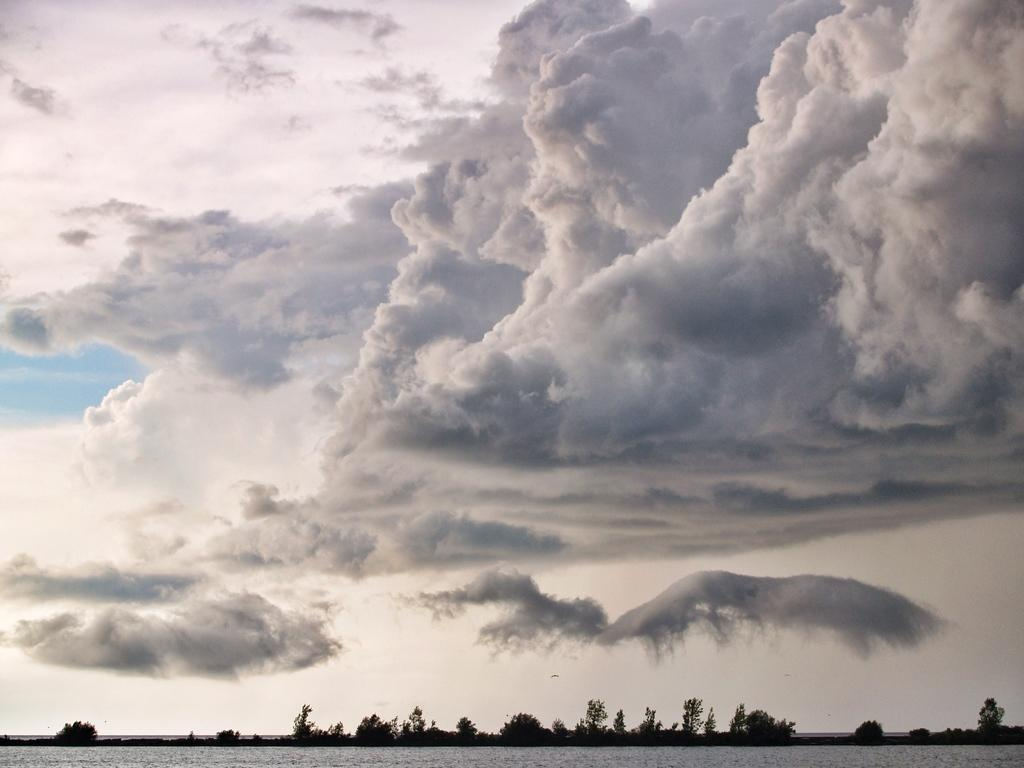What is present at the bottom of the image? There is water at the bottom of the image. What can be seen on the ground in the background of the image? There are trees in the background of the image. What is visible in the sky in the background of the image? There are clouds in the sky in the background of the image. Where is the oven located in the image? There is no oven present in the image. Can you describe the bed in the image? There is no bed present in the image. 